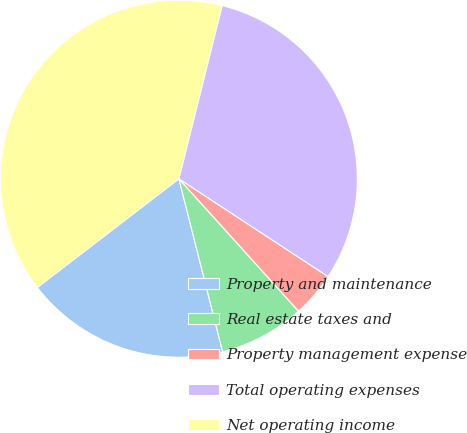Convert chart. <chart><loc_0><loc_0><loc_500><loc_500><pie_chart><fcel>Property and maintenance<fcel>Real estate taxes and<fcel>Property management expense<fcel>Total operating expenses<fcel>Net operating income<nl><fcel>18.52%<fcel>7.75%<fcel>4.07%<fcel>30.34%<fcel>39.32%<nl></chart> 